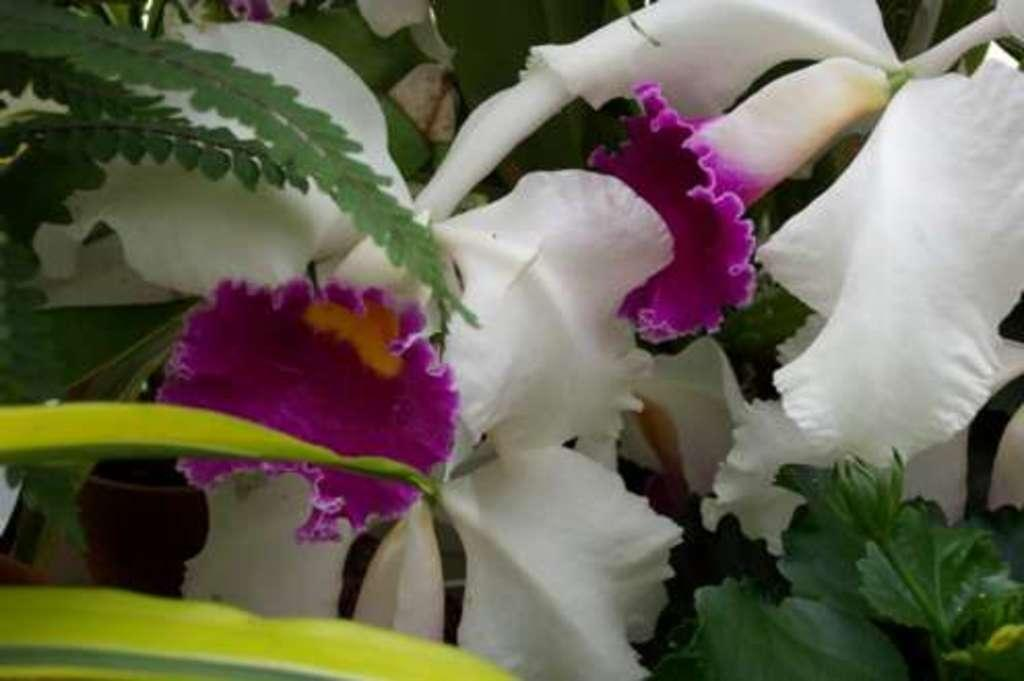What type of plant life can be seen in the image? There are flowers and leaves in the image. Can you describe the flowers in the image? Unfortunately, the facts provided do not give specific details about the flowers. What is the context of the image? The facts provided do not give any information about the context or setting of the image. What type of bone can be seen in the image? There is no bone present in the image; it only features flowers and leaves. How many crackers are visible in the image? There are no crackers present in the image; it only features flowers and leaves. 